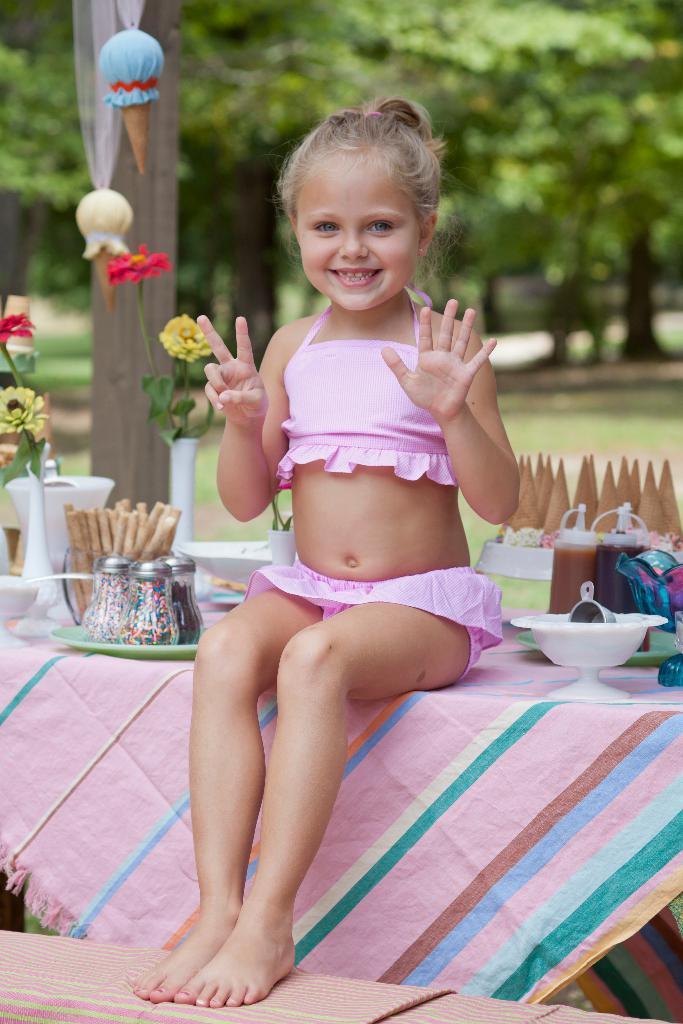How would you summarize this image in a sentence or two? This image is taken in outdoors. In the middle of the image a girl is sitting on the table and placing her hands on the stool. In this image there is a table with table cloth on it and there are few food items, sprinkler bottles, plate, bowl, flower vase with flowers are there on it. In the background there are many trees. At the top of the image a toy ice cream is tied. 